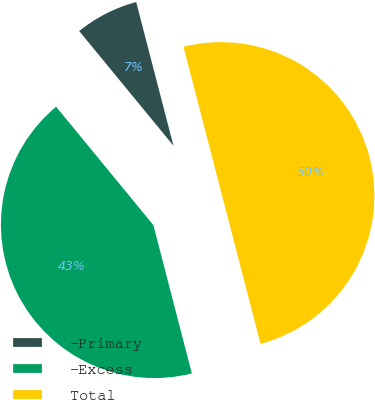Convert chart to OTSL. <chart><loc_0><loc_0><loc_500><loc_500><pie_chart><fcel>-Primary<fcel>-Excess<fcel>Total<nl><fcel>6.91%<fcel>43.09%<fcel>50.0%<nl></chart> 